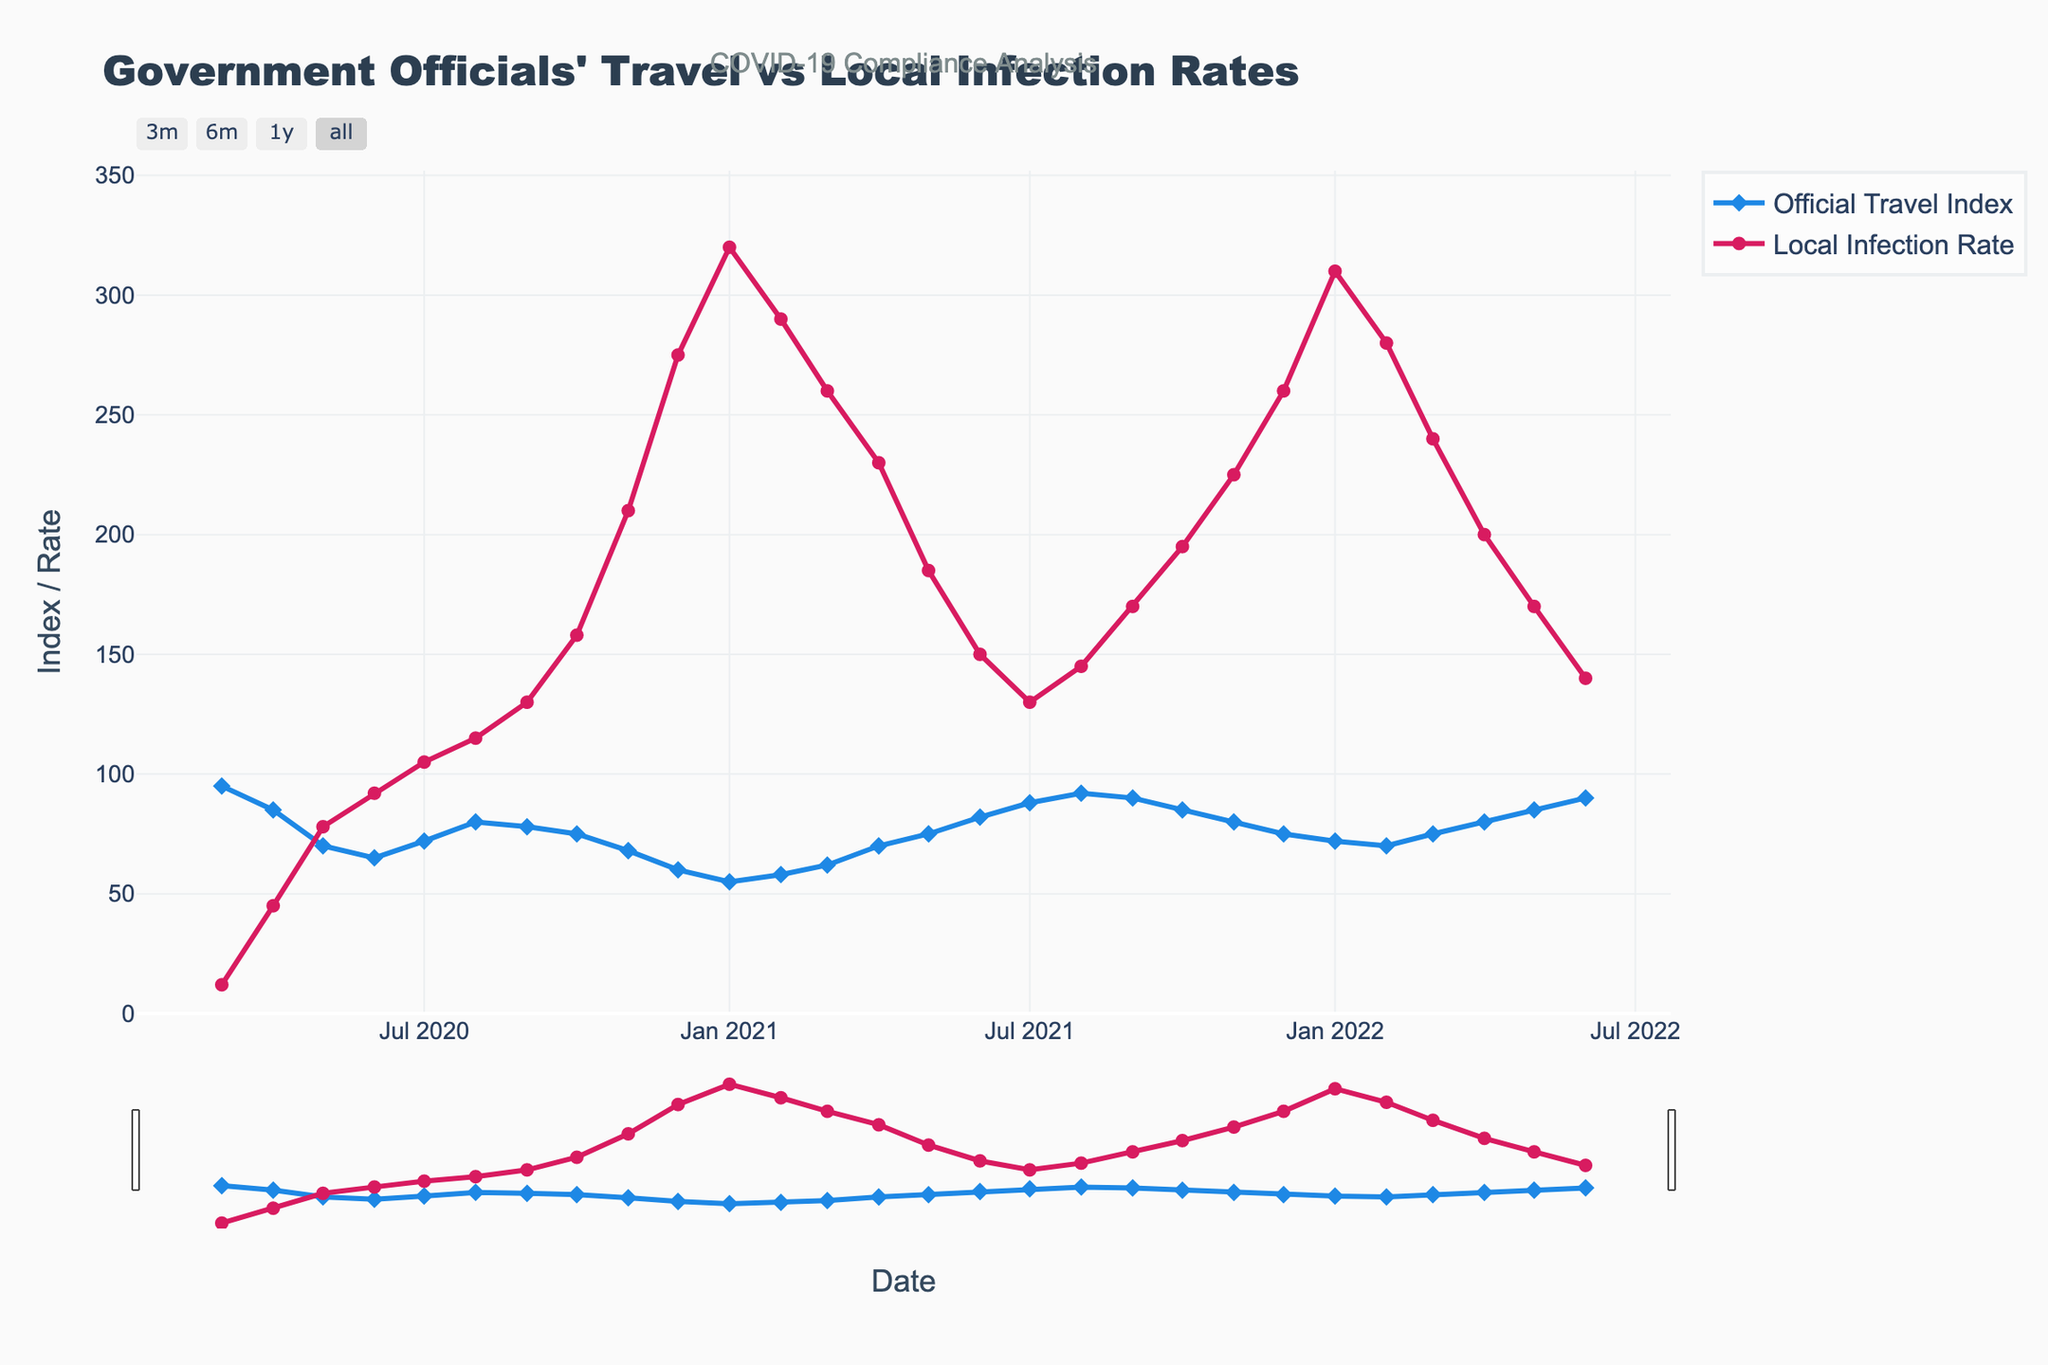What was the general trend in the Official Travel Index from March 2020 to December 2020? The Official Travel Index decreased steadily from March 2020 (95) to December 2020 (60).
Answer: Decreasing Between which months in 2020 did the Local Infection Rate increase the most, and by how much? The Local Infection Rate increased the most between October 2020 (158) and November 2020 (210), which is an increase of 52.
Answer: October to November, by 52 In what month of 2021 did the Official Travel Index start increasing after hitting its lowest point, and what was that point? The Official Travel Index hit its lowest point in January 2021 (55) and started increasing in February 2021.
Answer: February 2021, 55 How do the overall trends in Official Travel Index and Local Infection Rate compare from 2020 to 2021? The Official Travel Index generally decreased and then slightly increased by the end of 2021, while the Local Infection Rate followed a similar pattern, peaking early in 2021 and then decreasing gradually towards the end of the year.
Answer: Similar initial decrease, followed by an increase During which month in 2020 did the Local Infection Rate exceed the Official Travel Index by the largest amount, and by how much? In December 2020, the Local Infection Rate (275) exceeded the Official Travel Index (60) by the largest amount, which is 215.
Answer: December 2020, by 215 In what year and month was the Official Travel Index closest to the Local Infection Rate and what were the values? In January 2021, the Official Travel Index (55) was closest to the Local Infection Rate (320). The difference was the smallest observed.
Answer: January 2021, Official Travel Index: 55, Local Infection Rate: 320 What visual differences are there between the markers used for the Official Travel Index and Local Infection Rate? The Official Travel Index uses diamond markers in blue, while the Local Infection Rate uses circle markers in red.
Answer: Diamond blue vs Circle red By how much did the Official Travel Index increase from January 2021 to June 2022? The Official Travel Index increased from 55 in January 2021 to 90 in June 2022, making an overall increase of 35.
Answer: 35 During which range of months did the Local Infection Rate consistently decrease in 2021? The Local Infection Rate consistently decreased from January 2021 (320) to July 2021 (130).
Answer: January to July 2021 